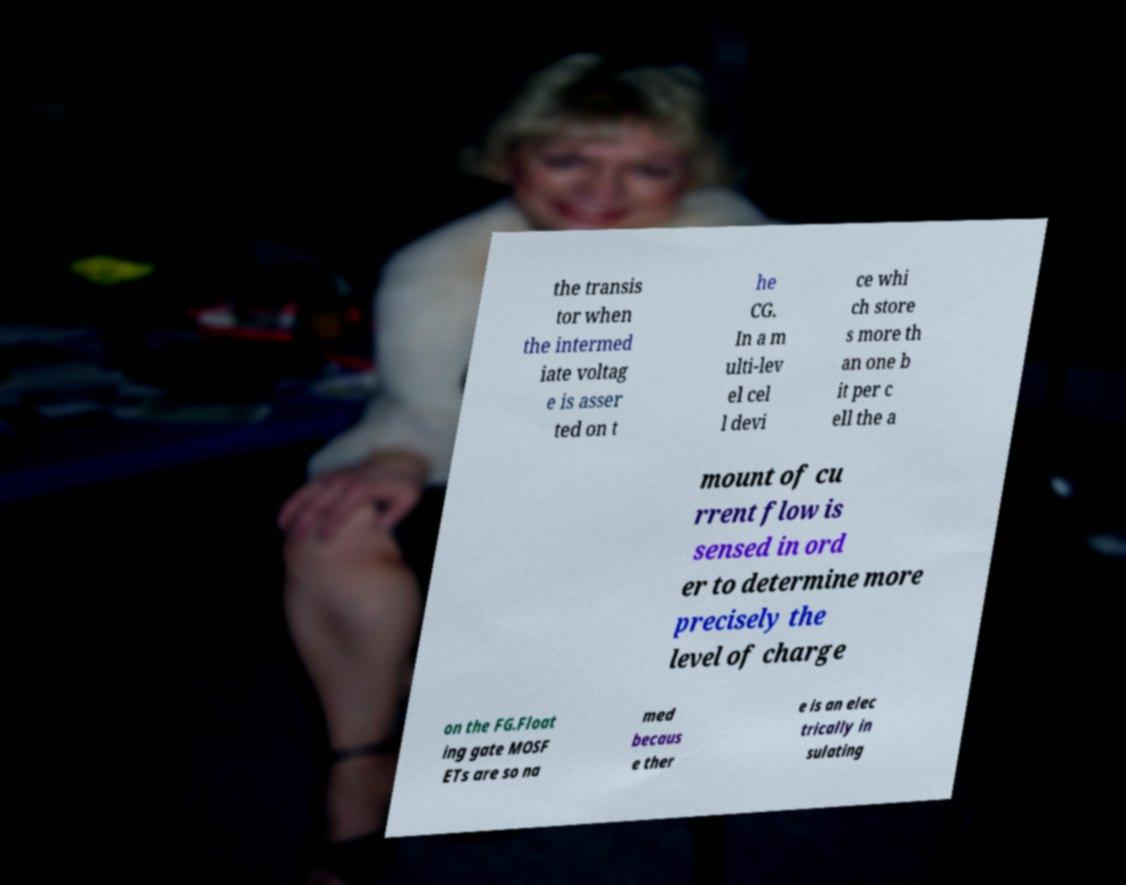Can you read and provide the text displayed in the image?This photo seems to have some interesting text. Can you extract and type it out for me? the transis tor when the intermed iate voltag e is asser ted on t he CG. In a m ulti-lev el cel l devi ce whi ch store s more th an one b it per c ell the a mount of cu rrent flow is sensed in ord er to determine more precisely the level of charge on the FG.Float ing gate MOSF ETs are so na med becaus e ther e is an elec trically in sulating 